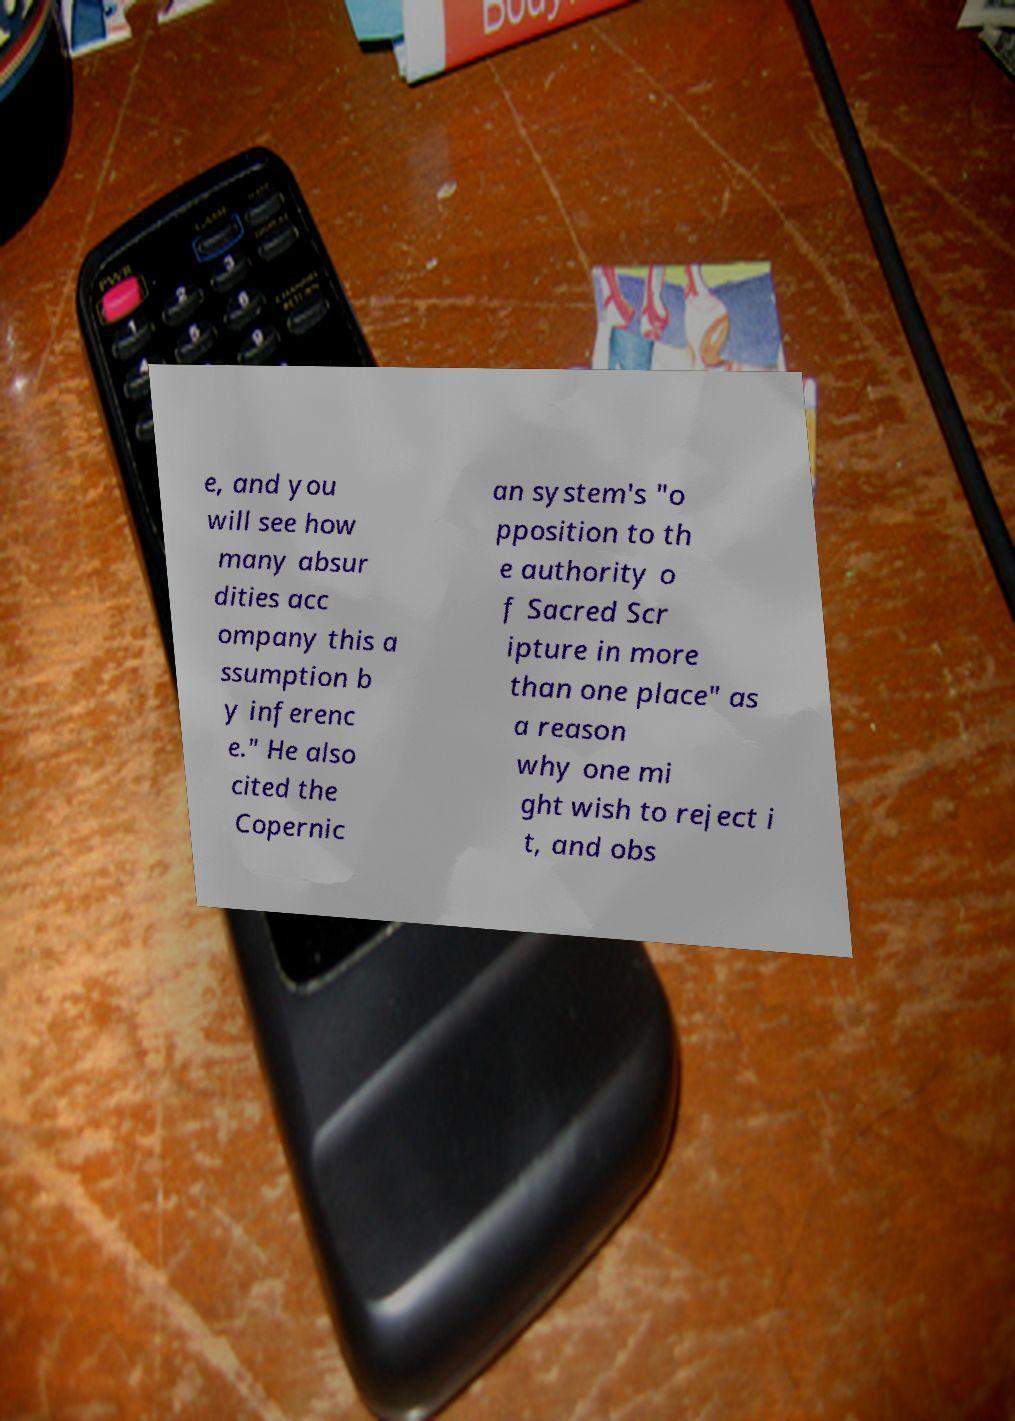Please identify and transcribe the text found in this image. e, and you will see how many absur dities acc ompany this a ssumption b y inferenc e." He also cited the Copernic an system's "o pposition to th e authority o f Sacred Scr ipture in more than one place" as a reason why one mi ght wish to reject i t, and obs 